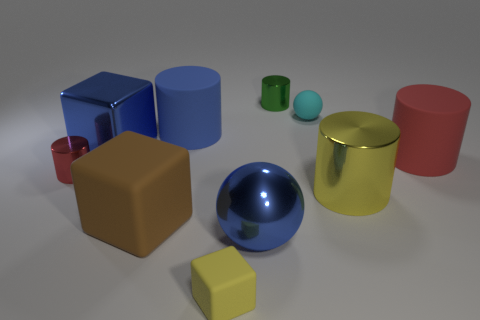How many objects of different colors can you identify? In the image, there are several objects with distinct colors. If we classify by unique colors, I identify six: a blue sphere, a red cylinder, a green small cylinder, a gold cylinder, a tan cube, and a yellow cube. 